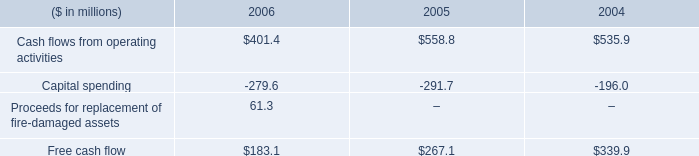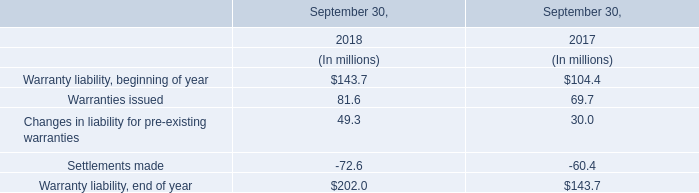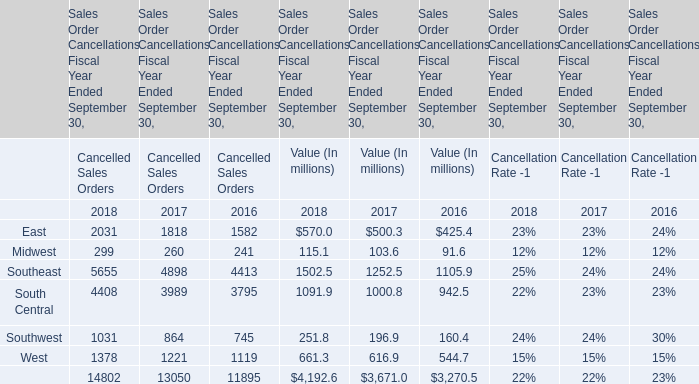What's the current increasing rate of Value of the total Cancelled Sales Orders? 
Computations: ((4192.6 - 3671.0) / 3671.0)
Answer: 0.14209. 